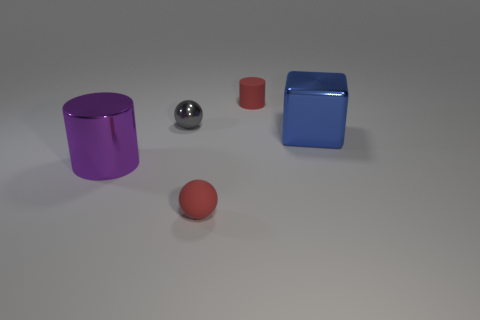Add 5 small metal objects. How many objects exist? 10 Subtract all cubes. How many objects are left? 4 Add 1 small brown matte spheres. How many small brown matte spheres exist? 1 Subtract 0 gray cylinders. How many objects are left? 5 Subtract all tiny purple matte spheres. Subtract all rubber cylinders. How many objects are left? 4 Add 3 large purple things. How many large purple things are left? 4 